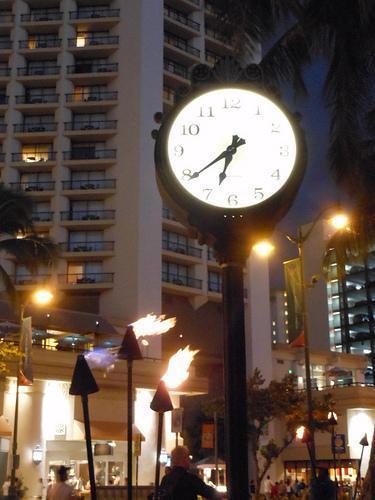How many clocks are there?
Give a very brief answer. 1. 